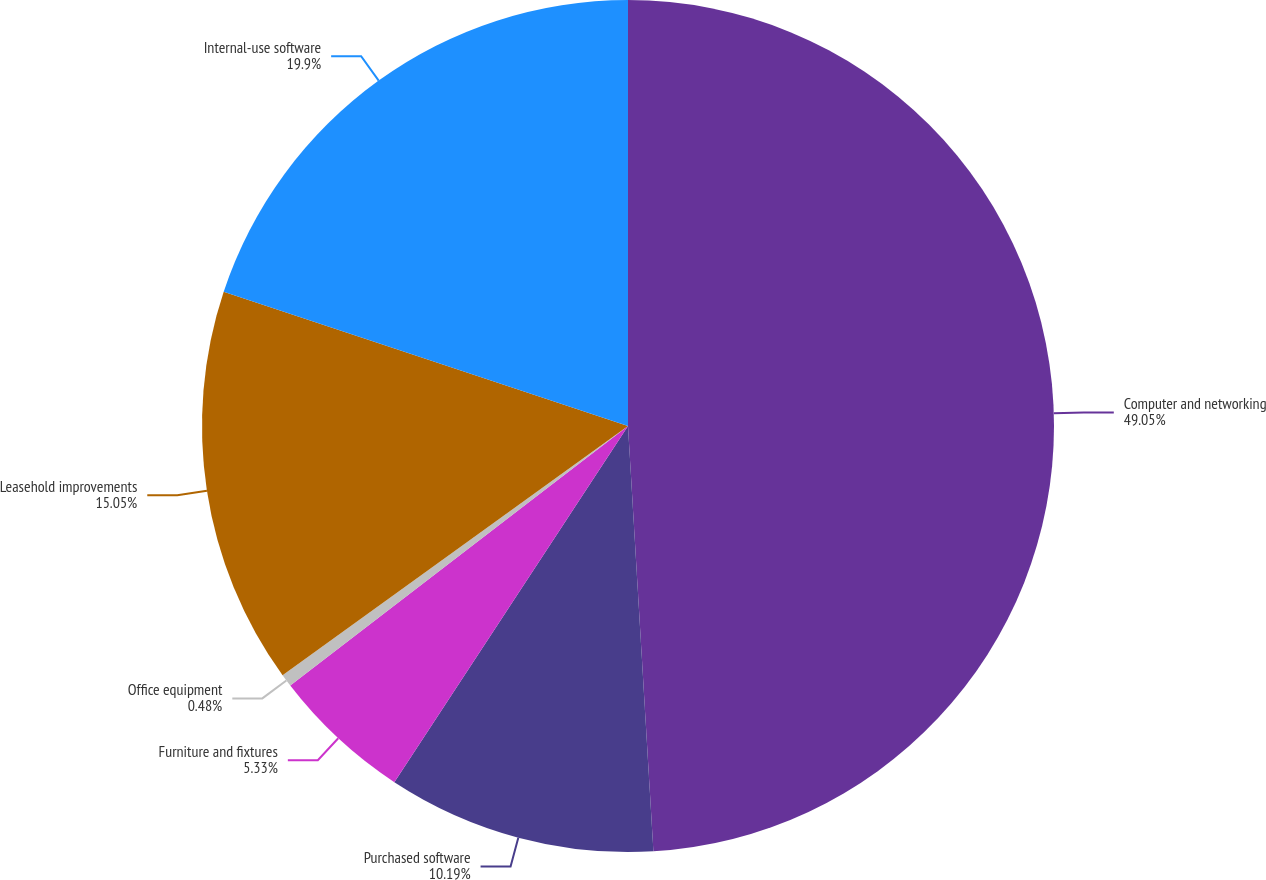Convert chart. <chart><loc_0><loc_0><loc_500><loc_500><pie_chart><fcel>Computer and networking<fcel>Purchased software<fcel>Furniture and fixtures<fcel>Office equipment<fcel>Leasehold improvements<fcel>Internal-use software<nl><fcel>49.05%<fcel>10.19%<fcel>5.33%<fcel>0.48%<fcel>15.05%<fcel>19.9%<nl></chart> 